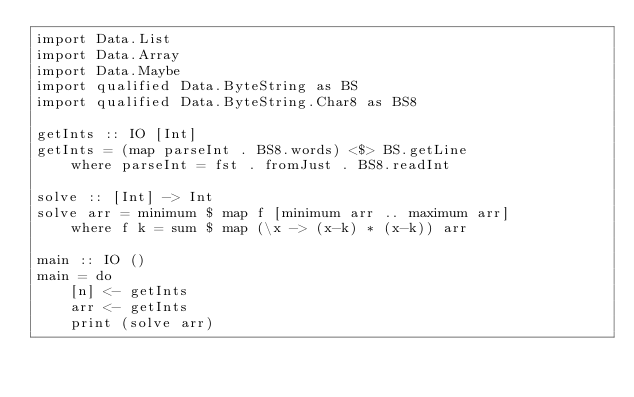<code> <loc_0><loc_0><loc_500><loc_500><_Haskell_>import Data.List
import Data.Array
import Data.Maybe
import qualified Data.ByteString as BS
import qualified Data.ByteString.Char8 as BS8
 
getInts :: IO [Int]
getInts = (map parseInt . BS8.words) <$> BS.getLine 
    where parseInt = fst . fromJust . BS8.readInt
 
solve :: [Int] -> Int
solve arr = minimum $ map f [minimum arr .. maximum arr]
    where f k = sum $ map (\x -> (x-k) * (x-k)) arr

main :: IO ()
main = do
    [n] <- getInts
    arr <- getInts
    print (solve arr)</code> 